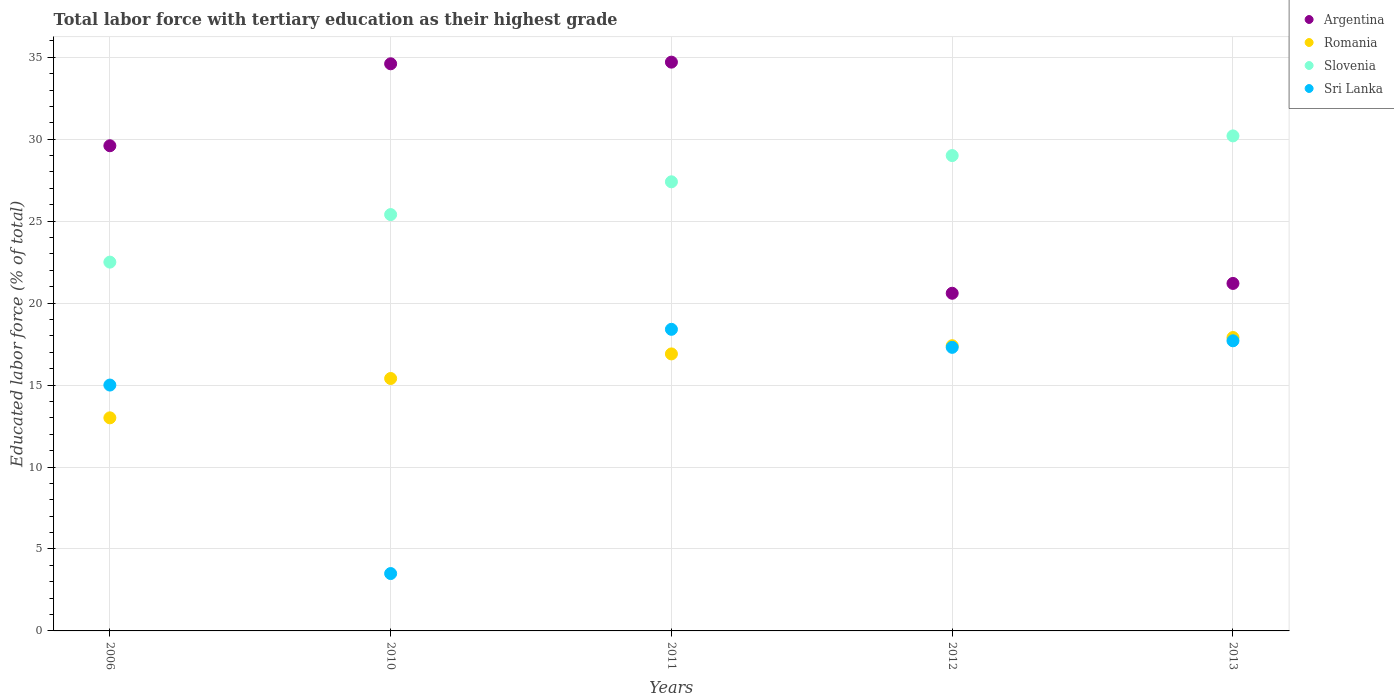How many different coloured dotlines are there?
Provide a succinct answer. 4. Across all years, what is the maximum percentage of male labor force with tertiary education in Argentina?
Your answer should be compact. 34.7. Across all years, what is the minimum percentage of male labor force with tertiary education in Sri Lanka?
Keep it short and to the point. 3.5. In which year was the percentage of male labor force with tertiary education in Sri Lanka maximum?
Offer a terse response. 2011. In which year was the percentage of male labor force with tertiary education in Romania minimum?
Your answer should be compact. 2006. What is the total percentage of male labor force with tertiary education in Argentina in the graph?
Offer a terse response. 140.7. What is the difference between the percentage of male labor force with tertiary education in Romania in 2006 and that in 2013?
Provide a short and direct response. -4.9. What is the difference between the percentage of male labor force with tertiary education in Romania in 2013 and the percentage of male labor force with tertiary education in Slovenia in 2012?
Provide a succinct answer. -11.1. What is the average percentage of male labor force with tertiary education in Romania per year?
Offer a terse response. 16.12. What is the ratio of the percentage of male labor force with tertiary education in Sri Lanka in 2010 to that in 2011?
Your answer should be compact. 0.19. What is the difference between the highest and the second highest percentage of male labor force with tertiary education in Slovenia?
Ensure brevity in your answer.  1.2. What is the difference between the highest and the lowest percentage of male labor force with tertiary education in Romania?
Keep it short and to the point. 4.9. Is the sum of the percentage of male labor force with tertiary education in Sri Lanka in 2006 and 2013 greater than the maximum percentage of male labor force with tertiary education in Slovenia across all years?
Offer a terse response. Yes. Is it the case that in every year, the sum of the percentage of male labor force with tertiary education in Romania and percentage of male labor force with tertiary education in Argentina  is greater than the percentage of male labor force with tertiary education in Sri Lanka?
Provide a succinct answer. Yes. Is the percentage of male labor force with tertiary education in Slovenia strictly greater than the percentage of male labor force with tertiary education in Argentina over the years?
Your answer should be very brief. No. Is the percentage of male labor force with tertiary education in Slovenia strictly less than the percentage of male labor force with tertiary education in Sri Lanka over the years?
Your response must be concise. No. How many years are there in the graph?
Offer a very short reply. 5. Are the values on the major ticks of Y-axis written in scientific E-notation?
Offer a very short reply. No. Does the graph contain any zero values?
Give a very brief answer. No. Does the graph contain grids?
Your response must be concise. Yes. How many legend labels are there?
Your answer should be compact. 4. What is the title of the graph?
Keep it short and to the point. Total labor force with tertiary education as their highest grade. What is the label or title of the Y-axis?
Offer a very short reply. Educated labor force (% of total). What is the Educated labor force (% of total) in Argentina in 2006?
Keep it short and to the point. 29.6. What is the Educated labor force (% of total) in Slovenia in 2006?
Make the answer very short. 22.5. What is the Educated labor force (% of total) of Argentina in 2010?
Provide a succinct answer. 34.6. What is the Educated labor force (% of total) in Romania in 2010?
Offer a terse response. 15.4. What is the Educated labor force (% of total) of Slovenia in 2010?
Offer a very short reply. 25.4. What is the Educated labor force (% of total) of Argentina in 2011?
Provide a short and direct response. 34.7. What is the Educated labor force (% of total) of Romania in 2011?
Provide a succinct answer. 16.9. What is the Educated labor force (% of total) of Slovenia in 2011?
Your response must be concise. 27.4. What is the Educated labor force (% of total) of Sri Lanka in 2011?
Keep it short and to the point. 18.4. What is the Educated labor force (% of total) of Argentina in 2012?
Provide a succinct answer. 20.6. What is the Educated labor force (% of total) of Romania in 2012?
Make the answer very short. 17.4. What is the Educated labor force (% of total) of Sri Lanka in 2012?
Make the answer very short. 17.3. What is the Educated labor force (% of total) in Argentina in 2013?
Your answer should be compact. 21.2. What is the Educated labor force (% of total) in Romania in 2013?
Provide a short and direct response. 17.9. What is the Educated labor force (% of total) of Slovenia in 2013?
Your response must be concise. 30.2. What is the Educated labor force (% of total) in Sri Lanka in 2013?
Make the answer very short. 17.7. Across all years, what is the maximum Educated labor force (% of total) of Argentina?
Provide a short and direct response. 34.7. Across all years, what is the maximum Educated labor force (% of total) in Romania?
Keep it short and to the point. 17.9. Across all years, what is the maximum Educated labor force (% of total) in Slovenia?
Offer a very short reply. 30.2. Across all years, what is the maximum Educated labor force (% of total) in Sri Lanka?
Ensure brevity in your answer.  18.4. Across all years, what is the minimum Educated labor force (% of total) in Argentina?
Keep it short and to the point. 20.6. Across all years, what is the minimum Educated labor force (% of total) in Sri Lanka?
Offer a very short reply. 3.5. What is the total Educated labor force (% of total) of Argentina in the graph?
Offer a very short reply. 140.7. What is the total Educated labor force (% of total) in Romania in the graph?
Give a very brief answer. 80.6. What is the total Educated labor force (% of total) of Slovenia in the graph?
Your answer should be very brief. 134.5. What is the total Educated labor force (% of total) of Sri Lanka in the graph?
Offer a very short reply. 71.9. What is the difference between the Educated labor force (% of total) in Slovenia in 2006 and that in 2010?
Your response must be concise. -2.9. What is the difference between the Educated labor force (% of total) of Sri Lanka in 2006 and that in 2011?
Offer a very short reply. -3.4. What is the difference between the Educated labor force (% of total) of Argentina in 2006 and that in 2012?
Your answer should be compact. 9. What is the difference between the Educated labor force (% of total) of Romania in 2006 and that in 2012?
Your answer should be very brief. -4.4. What is the difference between the Educated labor force (% of total) of Slovenia in 2006 and that in 2012?
Offer a terse response. -6.5. What is the difference between the Educated labor force (% of total) in Sri Lanka in 2006 and that in 2012?
Give a very brief answer. -2.3. What is the difference between the Educated labor force (% of total) in Argentina in 2006 and that in 2013?
Keep it short and to the point. 8.4. What is the difference between the Educated labor force (% of total) in Sri Lanka in 2006 and that in 2013?
Ensure brevity in your answer.  -2.7. What is the difference between the Educated labor force (% of total) in Argentina in 2010 and that in 2011?
Ensure brevity in your answer.  -0.1. What is the difference between the Educated labor force (% of total) of Romania in 2010 and that in 2011?
Make the answer very short. -1.5. What is the difference between the Educated labor force (% of total) in Sri Lanka in 2010 and that in 2011?
Provide a succinct answer. -14.9. What is the difference between the Educated labor force (% of total) in Argentina in 2010 and that in 2012?
Provide a succinct answer. 14. What is the difference between the Educated labor force (% of total) in Argentina in 2010 and that in 2013?
Provide a succinct answer. 13.4. What is the difference between the Educated labor force (% of total) of Slovenia in 2010 and that in 2013?
Give a very brief answer. -4.8. What is the difference between the Educated labor force (% of total) in Sri Lanka in 2011 and that in 2012?
Keep it short and to the point. 1.1. What is the difference between the Educated labor force (% of total) of Argentina in 2011 and that in 2013?
Provide a short and direct response. 13.5. What is the difference between the Educated labor force (% of total) of Slovenia in 2011 and that in 2013?
Make the answer very short. -2.8. What is the difference between the Educated labor force (% of total) in Argentina in 2012 and that in 2013?
Give a very brief answer. -0.6. What is the difference between the Educated labor force (% of total) in Romania in 2012 and that in 2013?
Offer a very short reply. -0.5. What is the difference between the Educated labor force (% of total) of Sri Lanka in 2012 and that in 2013?
Your answer should be compact. -0.4. What is the difference between the Educated labor force (% of total) of Argentina in 2006 and the Educated labor force (% of total) of Sri Lanka in 2010?
Your response must be concise. 26.1. What is the difference between the Educated labor force (% of total) in Romania in 2006 and the Educated labor force (% of total) in Sri Lanka in 2010?
Make the answer very short. 9.5. What is the difference between the Educated labor force (% of total) in Slovenia in 2006 and the Educated labor force (% of total) in Sri Lanka in 2010?
Keep it short and to the point. 19. What is the difference between the Educated labor force (% of total) in Argentina in 2006 and the Educated labor force (% of total) in Sri Lanka in 2011?
Your answer should be very brief. 11.2. What is the difference between the Educated labor force (% of total) of Romania in 2006 and the Educated labor force (% of total) of Slovenia in 2011?
Offer a very short reply. -14.4. What is the difference between the Educated labor force (% of total) in Romania in 2006 and the Educated labor force (% of total) in Sri Lanka in 2011?
Make the answer very short. -5.4. What is the difference between the Educated labor force (% of total) of Argentina in 2006 and the Educated labor force (% of total) of Sri Lanka in 2012?
Provide a short and direct response. 12.3. What is the difference between the Educated labor force (% of total) of Argentina in 2006 and the Educated labor force (% of total) of Sri Lanka in 2013?
Your answer should be very brief. 11.9. What is the difference between the Educated labor force (% of total) in Romania in 2006 and the Educated labor force (% of total) in Slovenia in 2013?
Offer a very short reply. -17.2. What is the difference between the Educated labor force (% of total) in Romania in 2010 and the Educated labor force (% of total) in Slovenia in 2011?
Keep it short and to the point. -12. What is the difference between the Educated labor force (% of total) of Romania in 2010 and the Educated labor force (% of total) of Sri Lanka in 2011?
Your response must be concise. -3. What is the difference between the Educated labor force (% of total) in Slovenia in 2010 and the Educated labor force (% of total) in Sri Lanka in 2011?
Offer a terse response. 7. What is the difference between the Educated labor force (% of total) in Argentina in 2010 and the Educated labor force (% of total) in Slovenia in 2012?
Give a very brief answer. 5.6. What is the difference between the Educated labor force (% of total) of Romania in 2010 and the Educated labor force (% of total) of Slovenia in 2012?
Provide a short and direct response. -13.6. What is the difference between the Educated labor force (% of total) in Romania in 2010 and the Educated labor force (% of total) in Slovenia in 2013?
Make the answer very short. -14.8. What is the difference between the Educated labor force (% of total) of Slovenia in 2010 and the Educated labor force (% of total) of Sri Lanka in 2013?
Provide a succinct answer. 7.7. What is the difference between the Educated labor force (% of total) in Argentina in 2011 and the Educated labor force (% of total) in Sri Lanka in 2012?
Keep it short and to the point. 17.4. What is the difference between the Educated labor force (% of total) in Romania in 2011 and the Educated labor force (% of total) in Slovenia in 2012?
Make the answer very short. -12.1. What is the difference between the Educated labor force (% of total) in Argentina in 2011 and the Educated labor force (% of total) in Romania in 2013?
Offer a terse response. 16.8. What is the difference between the Educated labor force (% of total) of Argentina in 2011 and the Educated labor force (% of total) of Slovenia in 2013?
Offer a terse response. 4.5. What is the difference between the Educated labor force (% of total) of Romania in 2011 and the Educated labor force (% of total) of Sri Lanka in 2013?
Provide a short and direct response. -0.8. What is the difference between the Educated labor force (% of total) of Argentina in 2012 and the Educated labor force (% of total) of Romania in 2013?
Provide a short and direct response. 2.7. What is the difference between the Educated labor force (% of total) of Argentina in 2012 and the Educated labor force (% of total) of Slovenia in 2013?
Provide a succinct answer. -9.6. What is the difference between the Educated labor force (% of total) of Romania in 2012 and the Educated labor force (% of total) of Slovenia in 2013?
Offer a very short reply. -12.8. What is the difference between the Educated labor force (% of total) of Romania in 2012 and the Educated labor force (% of total) of Sri Lanka in 2013?
Give a very brief answer. -0.3. What is the average Educated labor force (% of total) of Argentina per year?
Your answer should be compact. 28.14. What is the average Educated labor force (% of total) of Romania per year?
Your answer should be very brief. 16.12. What is the average Educated labor force (% of total) in Slovenia per year?
Offer a very short reply. 26.9. What is the average Educated labor force (% of total) in Sri Lanka per year?
Provide a succinct answer. 14.38. In the year 2006, what is the difference between the Educated labor force (% of total) in Argentina and Educated labor force (% of total) in Romania?
Your response must be concise. 16.6. In the year 2006, what is the difference between the Educated labor force (% of total) in Argentina and Educated labor force (% of total) in Sri Lanka?
Offer a terse response. 14.6. In the year 2006, what is the difference between the Educated labor force (% of total) in Romania and Educated labor force (% of total) in Slovenia?
Your answer should be very brief. -9.5. In the year 2010, what is the difference between the Educated labor force (% of total) of Argentina and Educated labor force (% of total) of Romania?
Make the answer very short. 19.2. In the year 2010, what is the difference between the Educated labor force (% of total) in Argentina and Educated labor force (% of total) in Slovenia?
Your answer should be very brief. 9.2. In the year 2010, what is the difference between the Educated labor force (% of total) of Argentina and Educated labor force (% of total) of Sri Lanka?
Give a very brief answer. 31.1. In the year 2010, what is the difference between the Educated labor force (% of total) of Romania and Educated labor force (% of total) of Slovenia?
Your answer should be compact. -10. In the year 2010, what is the difference between the Educated labor force (% of total) of Romania and Educated labor force (% of total) of Sri Lanka?
Your answer should be compact. 11.9. In the year 2010, what is the difference between the Educated labor force (% of total) of Slovenia and Educated labor force (% of total) of Sri Lanka?
Your response must be concise. 21.9. In the year 2011, what is the difference between the Educated labor force (% of total) of Argentina and Educated labor force (% of total) of Romania?
Provide a short and direct response. 17.8. In the year 2011, what is the difference between the Educated labor force (% of total) of Argentina and Educated labor force (% of total) of Slovenia?
Offer a very short reply. 7.3. In the year 2011, what is the difference between the Educated labor force (% of total) in Romania and Educated labor force (% of total) in Sri Lanka?
Your answer should be very brief. -1.5. In the year 2012, what is the difference between the Educated labor force (% of total) in Romania and Educated labor force (% of total) in Slovenia?
Offer a very short reply. -11.6. In the year 2012, what is the difference between the Educated labor force (% of total) in Slovenia and Educated labor force (% of total) in Sri Lanka?
Offer a terse response. 11.7. In the year 2013, what is the difference between the Educated labor force (% of total) in Romania and Educated labor force (% of total) in Slovenia?
Provide a succinct answer. -12.3. In the year 2013, what is the difference between the Educated labor force (% of total) of Slovenia and Educated labor force (% of total) of Sri Lanka?
Offer a very short reply. 12.5. What is the ratio of the Educated labor force (% of total) of Argentina in 2006 to that in 2010?
Your answer should be very brief. 0.86. What is the ratio of the Educated labor force (% of total) of Romania in 2006 to that in 2010?
Provide a short and direct response. 0.84. What is the ratio of the Educated labor force (% of total) of Slovenia in 2006 to that in 2010?
Offer a terse response. 0.89. What is the ratio of the Educated labor force (% of total) in Sri Lanka in 2006 to that in 2010?
Offer a terse response. 4.29. What is the ratio of the Educated labor force (% of total) in Argentina in 2006 to that in 2011?
Make the answer very short. 0.85. What is the ratio of the Educated labor force (% of total) of Romania in 2006 to that in 2011?
Keep it short and to the point. 0.77. What is the ratio of the Educated labor force (% of total) of Slovenia in 2006 to that in 2011?
Your response must be concise. 0.82. What is the ratio of the Educated labor force (% of total) of Sri Lanka in 2006 to that in 2011?
Give a very brief answer. 0.82. What is the ratio of the Educated labor force (% of total) in Argentina in 2006 to that in 2012?
Provide a short and direct response. 1.44. What is the ratio of the Educated labor force (% of total) of Romania in 2006 to that in 2012?
Ensure brevity in your answer.  0.75. What is the ratio of the Educated labor force (% of total) of Slovenia in 2006 to that in 2012?
Your answer should be very brief. 0.78. What is the ratio of the Educated labor force (% of total) in Sri Lanka in 2006 to that in 2012?
Make the answer very short. 0.87. What is the ratio of the Educated labor force (% of total) of Argentina in 2006 to that in 2013?
Make the answer very short. 1.4. What is the ratio of the Educated labor force (% of total) of Romania in 2006 to that in 2013?
Your response must be concise. 0.73. What is the ratio of the Educated labor force (% of total) in Slovenia in 2006 to that in 2013?
Offer a very short reply. 0.74. What is the ratio of the Educated labor force (% of total) of Sri Lanka in 2006 to that in 2013?
Provide a short and direct response. 0.85. What is the ratio of the Educated labor force (% of total) in Argentina in 2010 to that in 2011?
Ensure brevity in your answer.  1. What is the ratio of the Educated labor force (% of total) of Romania in 2010 to that in 2011?
Offer a very short reply. 0.91. What is the ratio of the Educated labor force (% of total) in Slovenia in 2010 to that in 2011?
Provide a succinct answer. 0.93. What is the ratio of the Educated labor force (% of total) in Sri Lanka in 2010 to that in 2011?
Your response must be concise. 0.19. What is the ratio of the Educated labor force (% of total) of Argentina in 2010 to that in 2012?
Offer a terse response. 1.68. What is the ratio of the Educated labor force (% of total) of Romania in 2010 to that in 2012?
Offer a very short reply. 0.89. What is the ratio of the Educated labor force (% of total) of Slovenia in 2010 to that in 2012?
Your answer should be compact. 0.88. What is the ratio of the Educated labor force (% of total) of Sri Lanka in 2010 to that in 2012?
Offer a terse response. 0.2. What is the ratio of the Educated labor force (% of total) in Argentina in 2010 to that in 2013?
Give a very brief answer. 1.63. What is the ratio of the Educated labor force (% of total) in Romania in 2010 to that in 2013?
Make the answer very short. 0.86. What is the ratio of the Educated labor force (% of total) of Slovenia in 2010 to that in 2013?
Offer a very short reply. 0.84. What is the ratio of the Educated labor force (% of total) of Sri Lanka in 2010 to that in 2013?
Give a very brief answer. 0.2. What is the ratio of the Educated labor force (% of total) in Argentina in 2011 to that in 2012?
Keep it short and to the point. 1.68. What is the ratio of the Educated labor force (% of total) in Romania in 2011 to that in 2012?
Give a very brief answer. 0.97. What is the ratio of the Educated labor force (% of total) in Slovenia in 2011 to that in 2012?
Offer a terse response. 0.94. What is the ratio of the Educated labor force (% of total) in Sri Lanka in 2011 to that in 2012?
Your answer should be compact. 1.06. What is the ratio of the Educated labor force (% of total) of Argentina in 2011 to that in 2013?
Your answer should be compact. 1.64. What is the ratio of the Educated labor force (% of total) of Romania in 2011 to that in 2013?
Offer a very short reply. 0.94. What is the ratio of the Educated labor force (% of total) in Slovenia in 2011 to that in 2013?
Ensure brevity in your answer.  0.91. What is the ratio of the Educated labor force (% of total) of Sri Lanka in 2011 to that in 2013?
Your answer should be compact. 1.04. What is the ratio of the Educated labor force (% of total) in Argentina in 2012 to that in 2013?
Make the answer very short. 0.97. What is the ratio of the Educated labor force (% of total) of Romania in 2012 to that in 2013?
Your answer should be compact. 0.97. What is the ratio of the Educated labor force (% of total) of Slovenia in 2012 to that in 2013?
Provide a short and direct response. 0.96. What is the ratio of the Educated labor force (% of total) in Sri Lanka in 2012 to that in 2013?
Provide a short and direct response. 0.98. What is the difference between the highest and the second highest Educated labor force (% of total) in Argentina?
Your answer should be very brief. 0.1. What is the difference between the highest and the second highest Educated labor force (% of total) of Romania?
Make the answer very short. 0.5. What is the difference between the highest and the second highest Educated labor force (% of total) in Sri Lanka?
Your response must be concise. 0.7. 